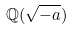<formula> <loc_0><loc_0><loc_500><loc_500>\mathbb { Q } ( { \sqrt { - a } } )</formula> 